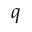<formula> <loc_0><loc_0><loc_500><loc_500>q</formula> 